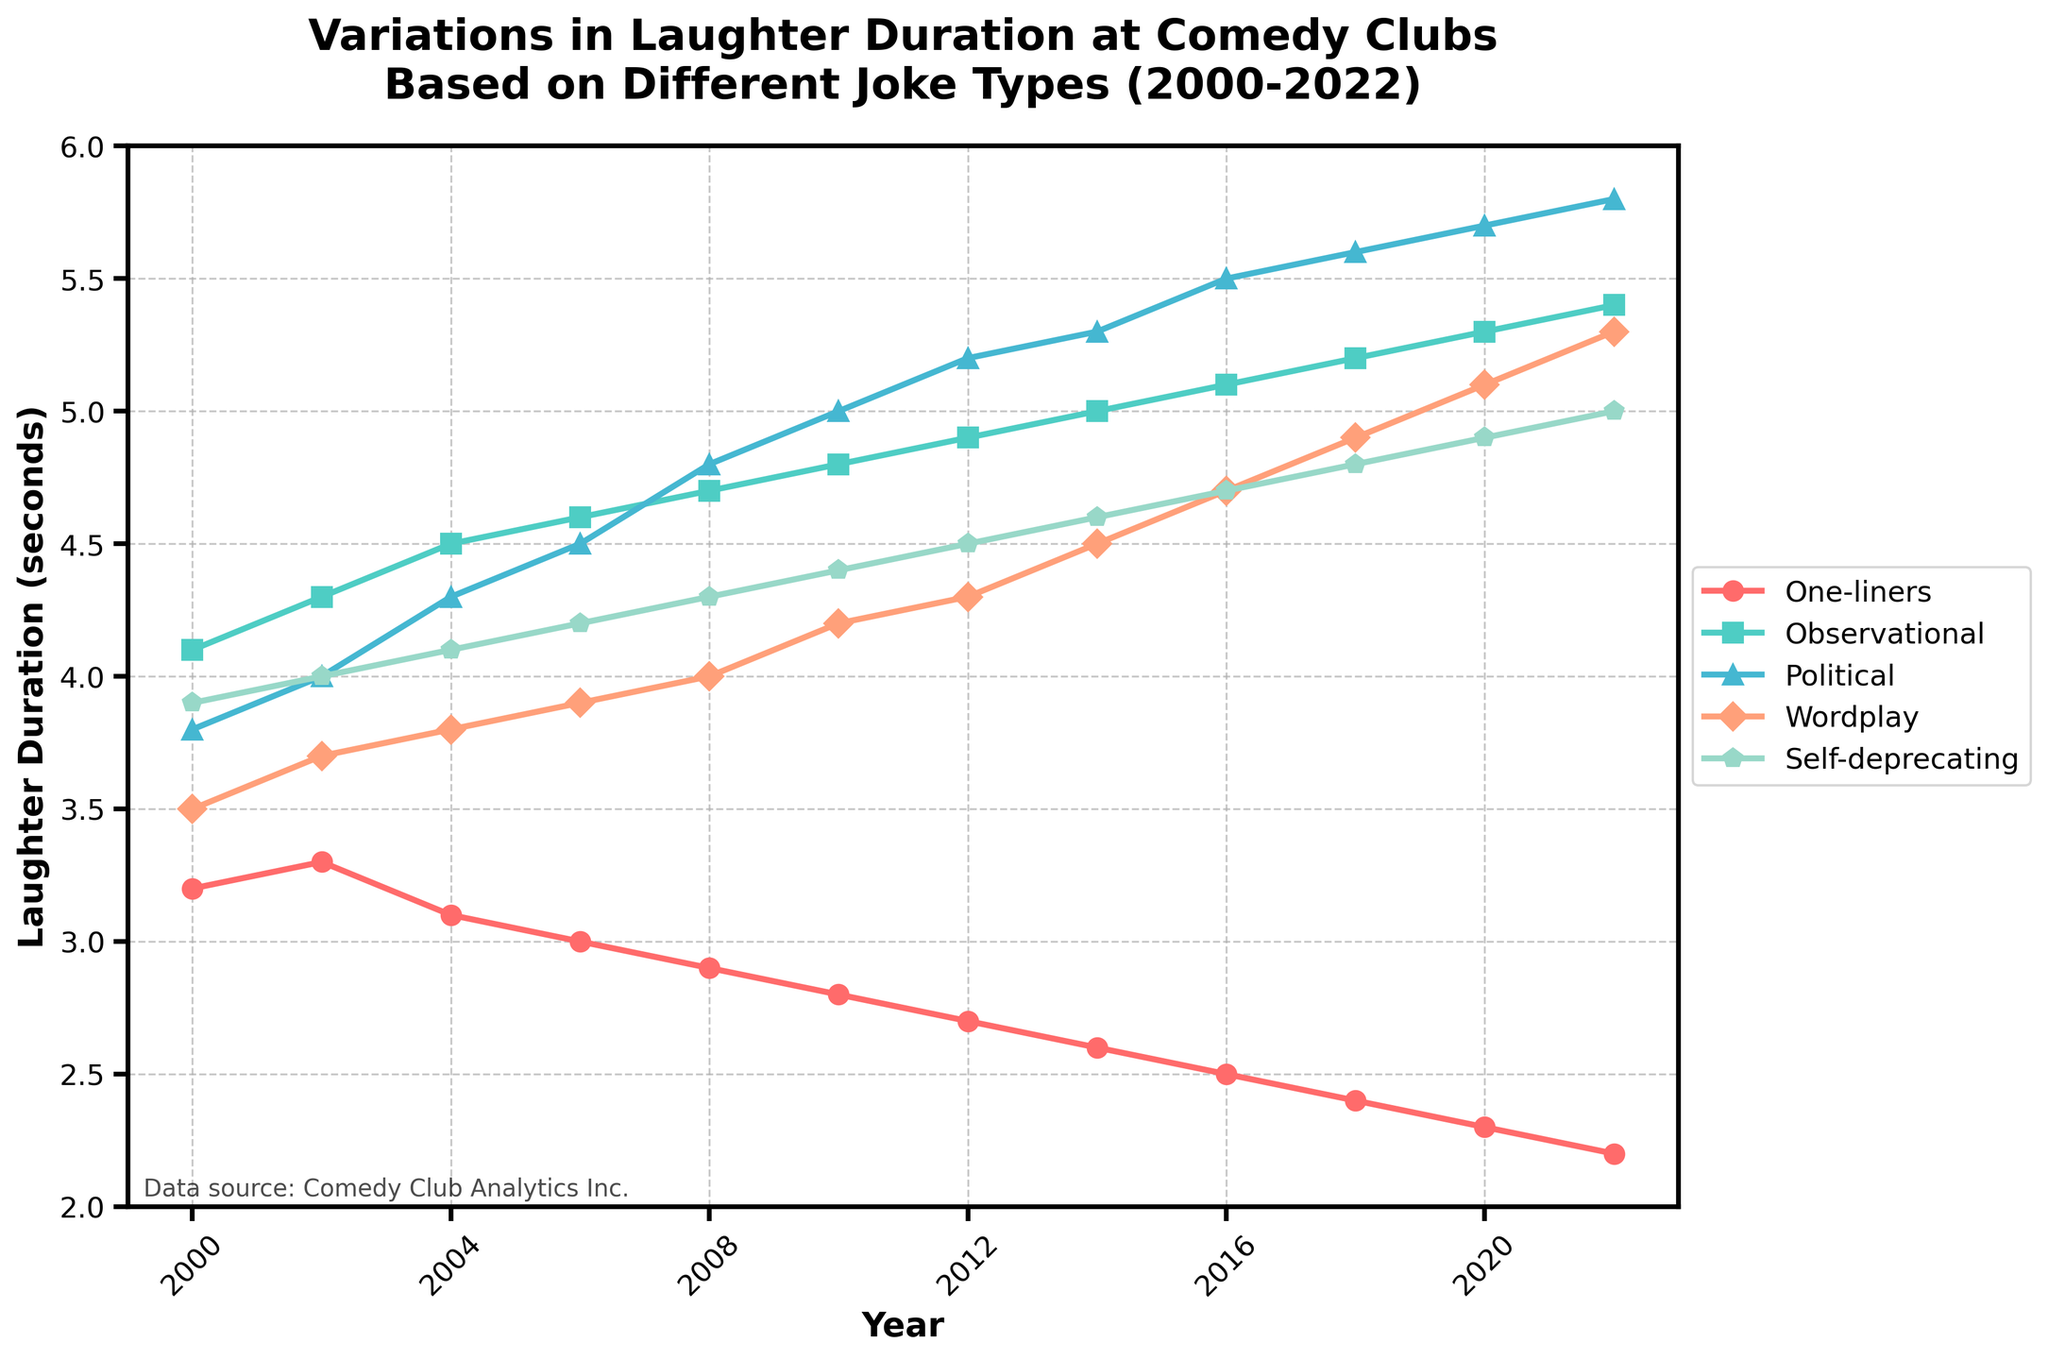What is the trend in laughter duration for observational jokes from 2000 to 2022? To identify the trend, observe the plot line for observational jokes on the graph from 2000 to 2022. The laughter duration steadily increases over time.
Answer: Increasing Which joke type had the shortest laughter duration in 2022? Look at the final year (2022) on the graph and compare the values for each joke type. The line representing one-liners is the lowest.
Answer: One-liners How did the laughter duration for political jokes change between 2008 and 2012? Locate 2008 and 2012 on the x-axis. Note the y-values for political jokes at these points. In 2008, it's 4.8 seconds, and in 2012, it's 5.2 seconds. The change is an increase of 0.4 seconds.
Answer: An increase of 0.4 seconds Compare the average laughter duration of wordplay jokes and self-deprecating jokes over the period from 2000 to 2022. Calculate the average for each joke type by summing their laughter durations from 2000 to 2022 and dividing by the number of years. Wordplay: (3.5+3.7+3.8+3.9+4.0+4.2+4.3+4.5+4.7+4.9+5.1+5.3)/12 = 4.23; Self-deprecating: (3.9+4.0+4.1+4.2+4.3+4.4+4.5+4.6+4.7+4.8+4.9+5.0)/12 = 4.45.
Answer: Wordplay: 4.23; Self-deprecating: 4.45 What is the difference between the highest laughter duration and the lowest laughter duration in the year 2016? Check the 2016 values for all joke types. Highest: Political jokes at 5.5 seconds. Lowest: One-liners at 2.5 seconds. The difference is 5.5 - 2.5 = 3.0 seconds.
Answer: 3.0 seconds Which joke type saw the most significant increase in laughter duration from 2000 to 2022? Evaluate the difference for each joke type from 2000 to 2022. One-liners: 3.2 to 2.2 (-1.0); Observational: 4.1 to 5.4 (1.3); Political: 3.8 to 5.8 (2.0); Wordplay: 3.5 to 5.3 (1.8); Self-deprecating: 3.9 to 5.0 (1.1). Political jokes saw the most significant increase of 2.0 seconds.
Answer: Political jokes In which year did self-deprecating jokes surpass a laughter duration of 4.5 seconds? Trace the self-deprecating jokes line and identify the first point where it exceeds 4.5 seconds. In 2014, the laughter duration is 4.6 seconds.
Answer: 2014 What is the average laughter duration for political jokes during the first decade (2000-2009)? Sum the values for political jokes from 2000 to 2009 and divide by 10. (3.8+4.0+4.3+4.5+4.8+5.0+5.2+5.3+5.5+5.6)/10 = 4.8 seconds.
Answer: 4.8 seconds 